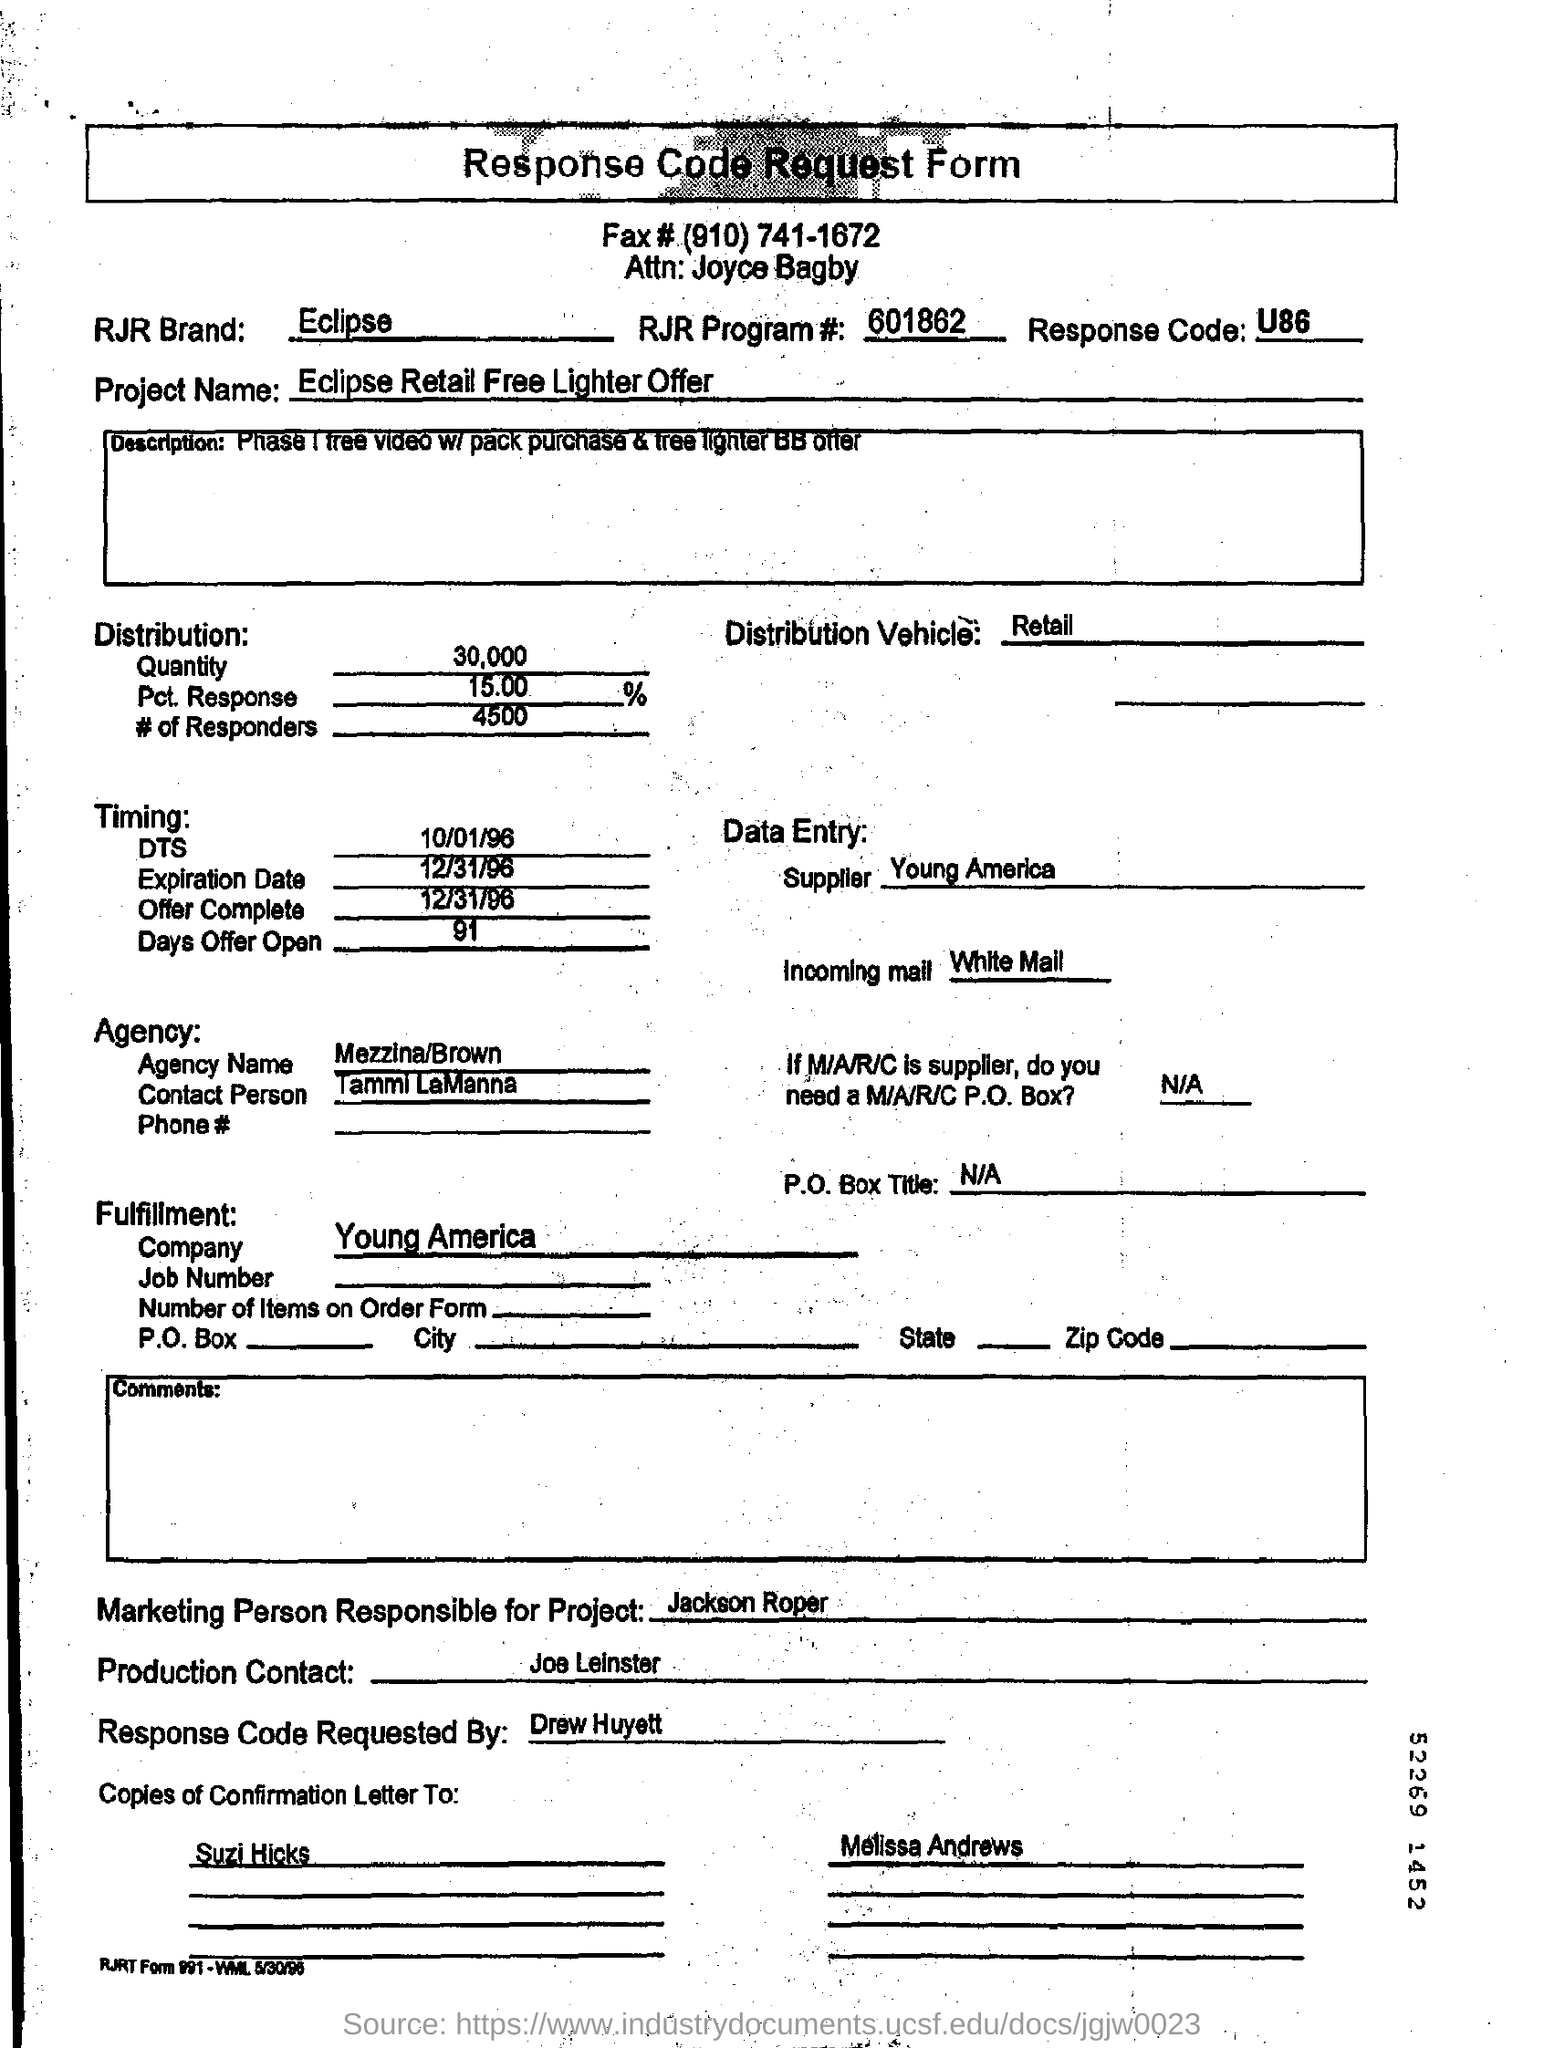What was the purpose of this form? Based on the content of the image, the purpose of this form was to request a response code for a marketing project related to the RJR brand Eclipse. The response code is used for tracking responses to the offer detailed in the form. 